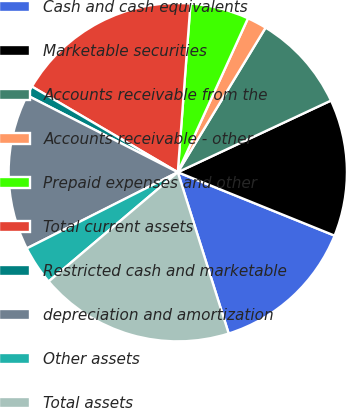Convert chart. <chart><loc_0><loc_0><loc_500><loc_500><pie_chart><fcel>Cash and cash equivalents<fcel>Marketable securities<fcel>Accounts receivable from the<fcel>Accounts receivable - other<fcel>Prepaid expenses and other<fcel>Total current assets<fcel>Restricted cash and marketable<fcel>depreciation and amortization<fcel>Other assets<fcel>Total assets<nl><fcel>14.02%<fcel>13.08%<fcel>9.35%<fcel>1.88%<fcel>5.61%<fcel>17.75%<fcel>0.94%<fcel>14.95%<fcel>3.74%<fcel>18.69%<nl></chart> 